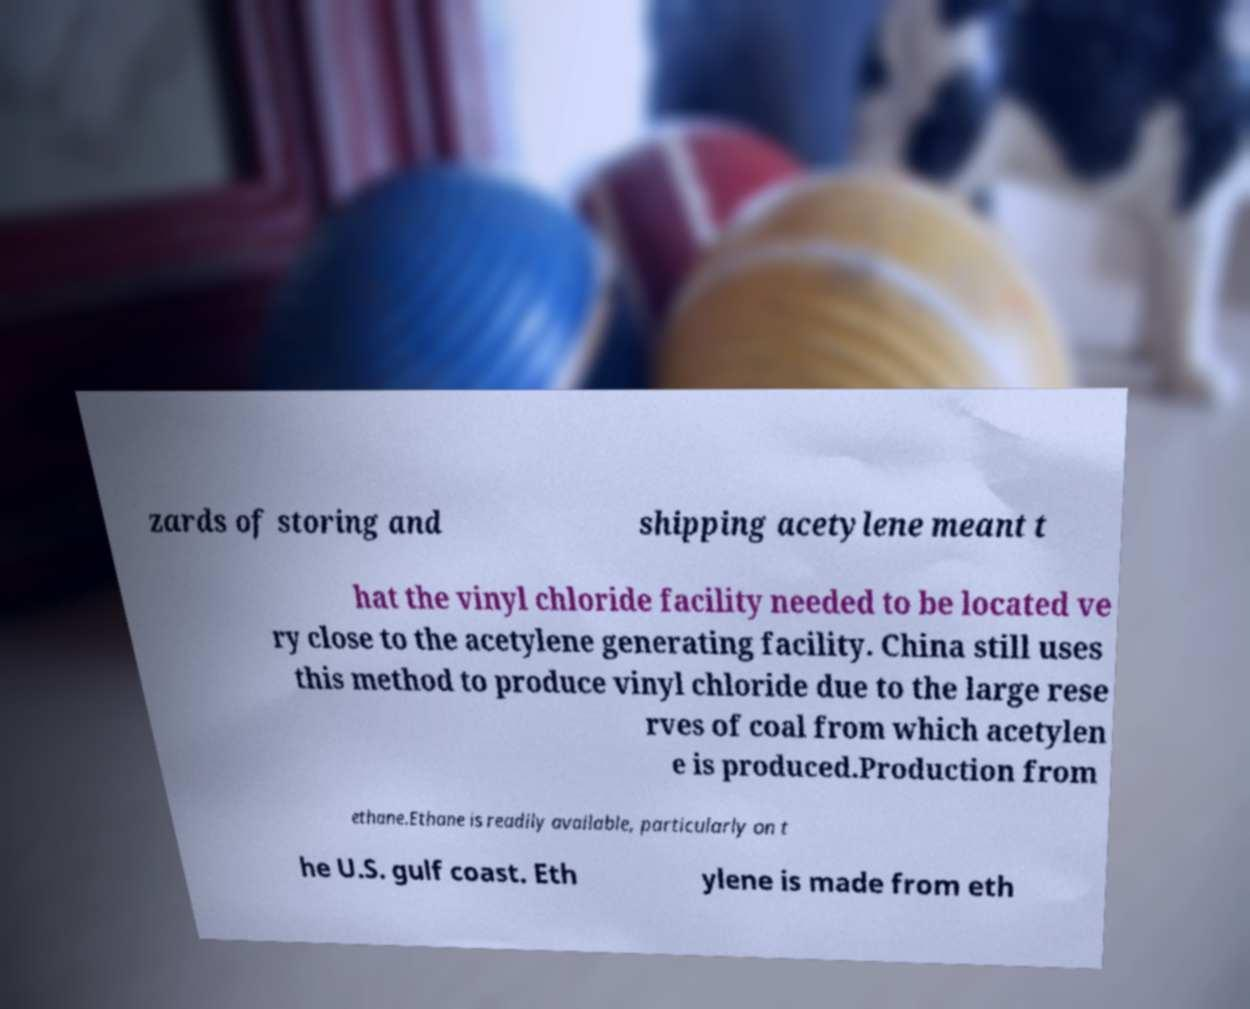Please read and relay the text visible in this image. What does it say? zards of storing and shipping acetylene meant t hat the vinyl chloride facility needed to be located ve ry close to the acetylene generating facility. China still uses this method to produce vinyl chloride due to the large rese rves of coal from which acetylen e is produced.Production from ethane.Ethane is readily available, particularly on t he U.S. gulf coast. Eth ylene is made from eth 